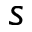Convert formula to latex. <formula><loc_0><loc_0><loc_500><loc_500>s</formula> 